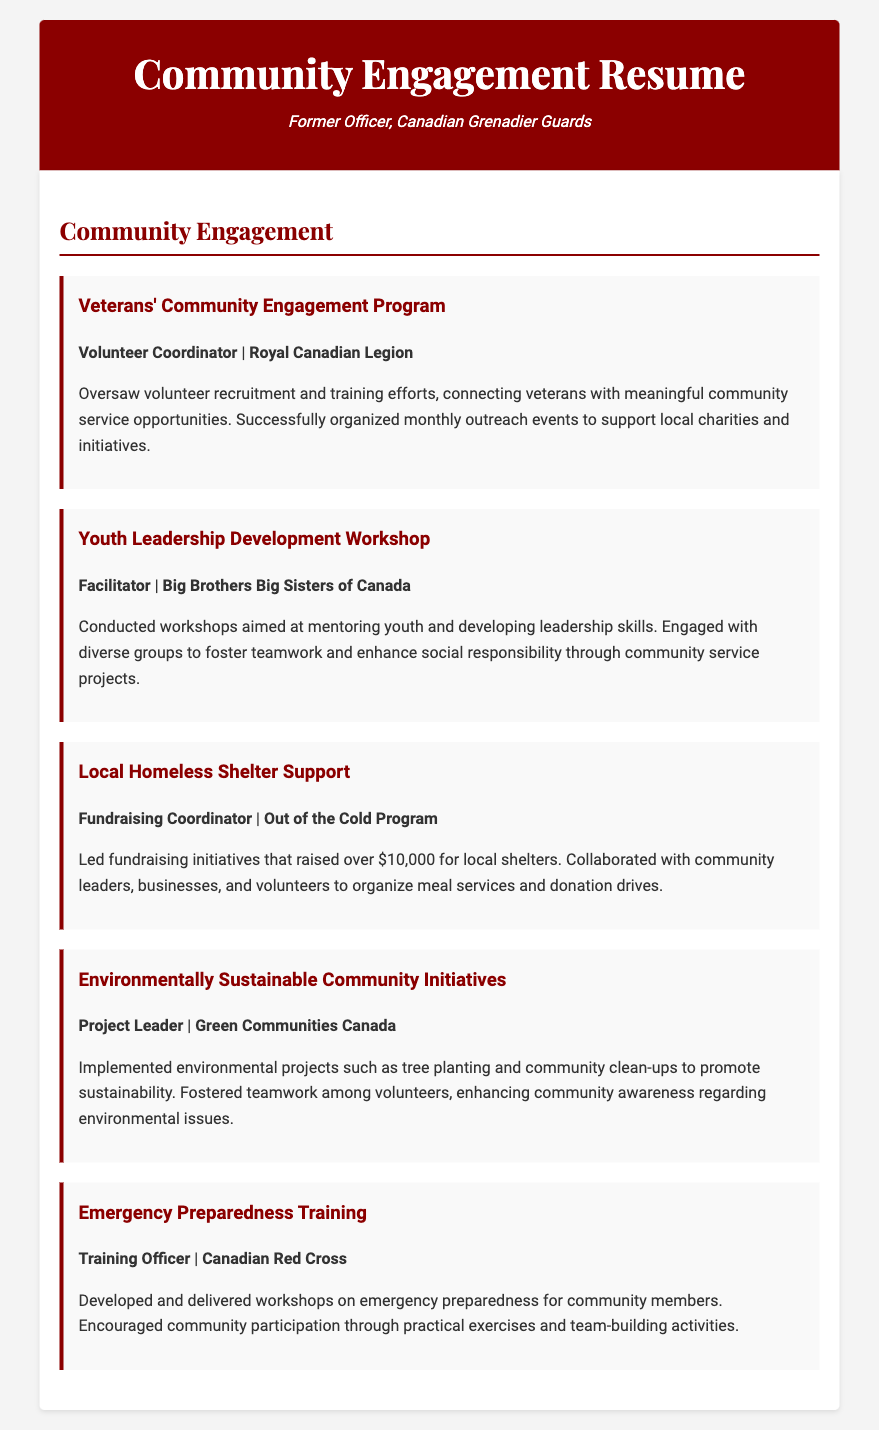what is the title of the document? The title of the document is stated at the top of the resume.
Answer: Community Engagement Resume who coordinated the Veterans' Community Engagement Program? The document lists the individual responsible for coordinating this program under their role in that initiative.
Answer: Volunteer Coordinator which organization is associated with the Youth Leadership Development Workshop? The organization mentioned in connection with this workshop is specified under the initiative description.
Answer: Big Brothers Big Sisters of Canada how much money was raised for local shelters by the Fundraising Coordinator? The amount raised is detailed within the description of that specific initiative.
Answer: over $10,000 what role did the individual play in the Emergency Preparedness Training initiative? The role is explicitly mentioned next to the initiative title.
Answer: Training Officer what was the focus of the Environmentally Sustainable Community Initiatives? The main objective of this initiative is outlined in the project description.
Answer: environmental projects which organization did the Project Leader collaborate with for community initiatives? The organization is mentioned at the end of the initiative description.
Answer: Green Communities Canada what type of workshops did the Training Officer develop? The type of workshops is described in the context of their initiatives and objectives.
Answer: emergency preparedness how did the Volunteer Coordinator support veterans? The support provided by this role is summarized in the description of their responsibilities.
Answer: connecting veterans with meaningful community service opportunities 